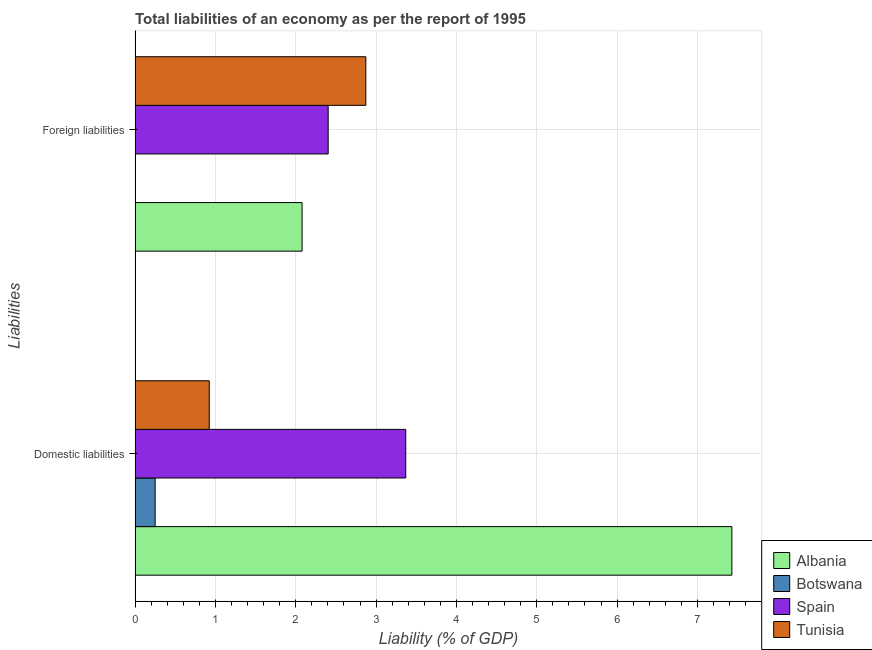How many different coloured bars are there?
Keep it short and to the point. 4. How many groups of bars are there?
Make the answer very short. 2. Are the number of bars per tick equal to the number of legend labels?
Provide a short and direct response. No. Are the number of bars on each tick of the Y-axis equal?
Offer a terse response. No. How many bars are there on the 2nd tick from the top?
Offer a terse response. 4. What is the label of the 2nd group of bars from the top?
Provide a succinct answer. Domestic liabilities. Across all countries, what is the maximum incurrence of domestic liabilities?
Your response must be concise. 7.43. Across all countries, what is the minimum incurrence of foreign liabilities?
Offer a very short reply. 0. In which country was the incurrence of foreign liabilities maximum?
Ensure brevity in your answer.  Tunisia. What is the total incurrence of domestic liabilities in the graph?
Your answer should be compact. 11.97. What is the difference between the incurrence of foreign liabilities in Tunisia and that in Spain?
Offer a terse response. 0.47. What is the difference between the incurrence of domestic liabilities in Albania and the incurrence of foreign liabilities in Botswana?
Offer a very short reply. 7.43. What is the average incurrence of domestic liabilities per country?
Offer a terse response. 2.99. What is the difference between the incurrence of domestic liabilities and incurrence of foreign liabilities in Tunisia?
Your answer should be very brief. -1.95. In how many countries, is the incurrence of foreign liabilities greater than 2.4 %?
Your answer should be very brief. 2. What is the ratio of the incurrence of domestic liabilities in Tunisia to that in Albania?
Give a very brief answer. 0.12. Is the incurrence of foreign liabilities in Albania less than that in Spain?
Ensure brevity in your answer.  Yes. In how many countries, is the incurrence of domestic liabilities greater than the average incurrence of domestic liabilities taken over all countries?
Offer a very short reply. 2. Are all the bars in the graph horizontal?
Your answer should be very brief. Yes. What is the difference between two consecutive major ticks on the X-axis?
Ensure brevity in your answer.  1. Does the graph contain any zero values?
Provide a succinct answer. Yes. Where does the legend appear in the graph?
Give a very brief answer. Bottom right. How many legend labels are there?
Make the answer very short. 4. How are the legend labels stacked?
Provide a short and direct response. Vertical. What is the title of the graph?
Make the answer very short. Total liabilities of an economy as per the report of 1995. Does "Venezuela" appear as one of the legend labels in the graph?
Ensure brevity in your answer.  No. What is the label or title of the X-axis?
Offer a terse response. Liability (% of GDP). What is the label or title of the Y-axis?
Your answer should be compact. Liabilities. What is the Liability (% of GDP) of Albania in Domestic liabilities?
Provide a succinct answer. 7.43. What is the Liability (% of GDP) in Botswana in Domestic liabilities?
Your answer should be compact. 0.25. What is the Liability (% of GDP) of Spain in Domestic liabilities?
Your response must be concise. 3.37. What is the Liability (% of GDP) in Tunisia in Domestic liabilities?
Offer a very short reply. 0.92. What is the Liability (% of GDP) of Albania in Foreign liabilities?
Give a very brief answer. 2.08. What is the Liability (% of GDP) in Botswana in Foreign liabilities?
Your answer should be very brief. 0. What is the Liability (% of GDP) of Spain in Foreign liabilities?
Provide a succinct answer. 2.4. What is the Liability (% of GDP) of Tunisia in Foreign liabilities?
Provide a short and direct response. 2.87. Across all Liabilities, what is the maximum Liability (% of GDP) in Albania?
Offer a very short reply. 7.43. Across all Liabilities, what is the maximum Liability (% of GDP) of Botswana?
Your response must be concise. 0.25. Across all Liabilities, what is the maximum Liability (% of GDP) in Spain?
Ensure brevity in your answer.  3.37. Across all Liabilities, what is the maximum Liability (% of GDP) in Tunisia?
Your answer should be very brief. 2.87. Across all Liabilities, what is the minimum Liability (% of GDP) of Albania?
Your answer should be compact. 2.08. Across all Liabilities, what is the minimum Liability (% of GDP) of Botswana?
Your response must be concise. 0. Across all Liabilities, what is the minimum Liability (% of GDP) in Spain?
Your answer should be compact. 2.4. Across all Liabilities, what is the minimum Liability (% of GDP) in Tunisia?
Offer a terse response. 0.92. What is the total Liability (% of GDP) in Albania in the graph?
Offer a terse response. 9.51. What is the total Liability (% of GDP) of Botswana in the graph?
Make the answer very short. 0.25. What is the total Liability (% of GDP) of Spain in the graph?
Your response must be concise. 5.77. What is the total Liability (% of GDP) in Tunisia in the graph?
Ensure brevity in your answer.  3.8. What is the difference between the Liability (% of GDP) in Albania in Domestic liabilities and that in Foreign liabilities?
Provide a short and direct response. 5.35. What is the difference between the Liability (% of GDP) of Spain in Domestic liabilities and that in Foreign liabilities?
Offer a very short reply. 0.97. What is the difference between the Liability (% of GDP) of Tunisia in Domestic liabilities and that in Foreign liabilities?
Your answer should be very brief. -1.95. What is the difference between the Liability (% of GDP) in Albania in Domestic liabilities and the Liability (% of GDP) in Spain in Foreign liabilities?
Give a very brief answer. 5.02. What is the difference between the Liability (% of GDP) of Albania in Domestic liabilities and the Liability (% of GDP) of Tunisia in Foreign liabilities?
Provide a short and direct response. 4.56. What is the difference between the Liability (% of GDP) of Botswana in Domestic liabilities and the Liability (% of GDP) of Spain in Foreign liabilities?
Offer a very short reply. -2.15. What is the difference between the Liability (% of GDP) of Botswana in Domestic liabilities and the Liability (% of GDP) of Tunisia in Foreign liabilities?
Offer a terse response. -2.62. What is the difference between the Liability (% of GDP) of Spain in Domestic liabilities and the Liability (% of GDP) of Tunisia in Foreign liabilities?
Your answer should be compact. 0.5. What is the average Liability (% of GDP) in Albania per Liabilities?
Offer a very short reply. 4.75. What is the average Liability (% of GDP) of Botswana per Liabilities?
Provide a succinct answer. 0.13. What is the average Liability (% of GDP) of Spain per Liabilities?
Keep it short and to the point. 2.89. What is the average Liability (% of GDP) of Tunisia per Liabilities?
Your answer should be very brief. 1.9. What is the difference between the Liability (% of GDP) in Albania and Liability (% of GDP) in Botswana in Domestic liabilities?
Your response must be concise. 7.18. What is the difference between the Liability (% of GDP) in Albania and Liability (% of GDP) in Spain in Domestic liabilities?
Keep it short and to the point. 4.06. What is the difference between the Liability (% of GDP) of Albania and Liability (% of GDP) of Tunisia in Domestic liabilities?
Provide a short and direct response. 6.5. What is the difference between the Liability (% of GDP) in Botswana and Liability (% of GDP) in Spain in Domestic liabilities?
Offer a very short reply. -3.12. What is the difference between the Liability (% of GDP) in Botswana and Liability (% of GDP) in Tunisia in Domestic liabilities?
Provide a short and direct response. -0.67. What is the difference between the Liability (% of GDP) of Spain and Liability (% of GDP) of Tunisia in Domestic liabilities?
Provide a short and direct response. 2.45. What is the difference between the Liability (% of GDP) of Albania and Liability (% of GDP) of Spain in Foreign liabilities?
Give a very brief answer. -0.32. What is the difference between the Liability (% of GDP) in Albania and Liability (% of GDP) in Tunisia in Foreign liabilities?
Offer a very short reply. -0.79. What is the difference between the Liability (% of GDP) of Spain and Liability (% of GDP) of Tunisia in Foreign liabilities?
Give a very brief answer. -0.47. What is the ratio of the Liability (% of GDP) in Albania in Domestic liabilities to that in Foreign liabilities?
Your answer should be very brief. 3.57. What is the ratio of the Liability (% of GDP) in Spain in Domestic liabilities to that in Foreign liabilities?
Offer a very short reply. 1.4. What is the ratio of the Liability (% of GDP) of Tunisia in Domestic liabilities to that in Foreign liabilities?
Give a very brief answer. 0.32. What is the difference between the highest and the second highest Liability (% of GDP) in Albania?
Your answer should be very brief. 5.35. What is the difference between the highest and the second highest Liability (% of GDP) of Spain?
Offer a terse response. 0.97. What is the difference between the highest and the second highest Liability (% of GDP) in Tunisia?
Give a very brief answer. 1.95. What is the difference between the highest and the lowest Liability (% of GDP) in Albania?
Give a very brief answer. 5.35. What is the difference between the highest and the lowest Liability (% of GDP) in Botswana?
Your answer should be very brief. 0.25. What is the difference between the highest and the lowest Liability (% of GDP) in Spain?
Your response must be concise. 0.97. What is the difference between the highest and the lowest Liability (% of GDP) in Tunisia?
Give a very brief answer. 1.95. 